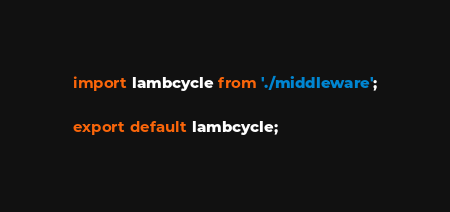Convert code to text. <code><loc_0><loc_0><loc_500><loc_500><_TypeScript_>import lambcycle from './middleware';

export default lambcycle;
</code> 